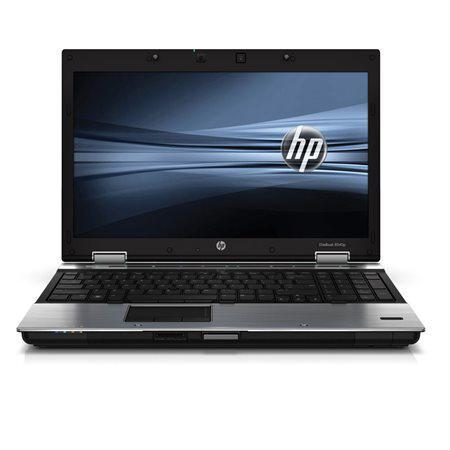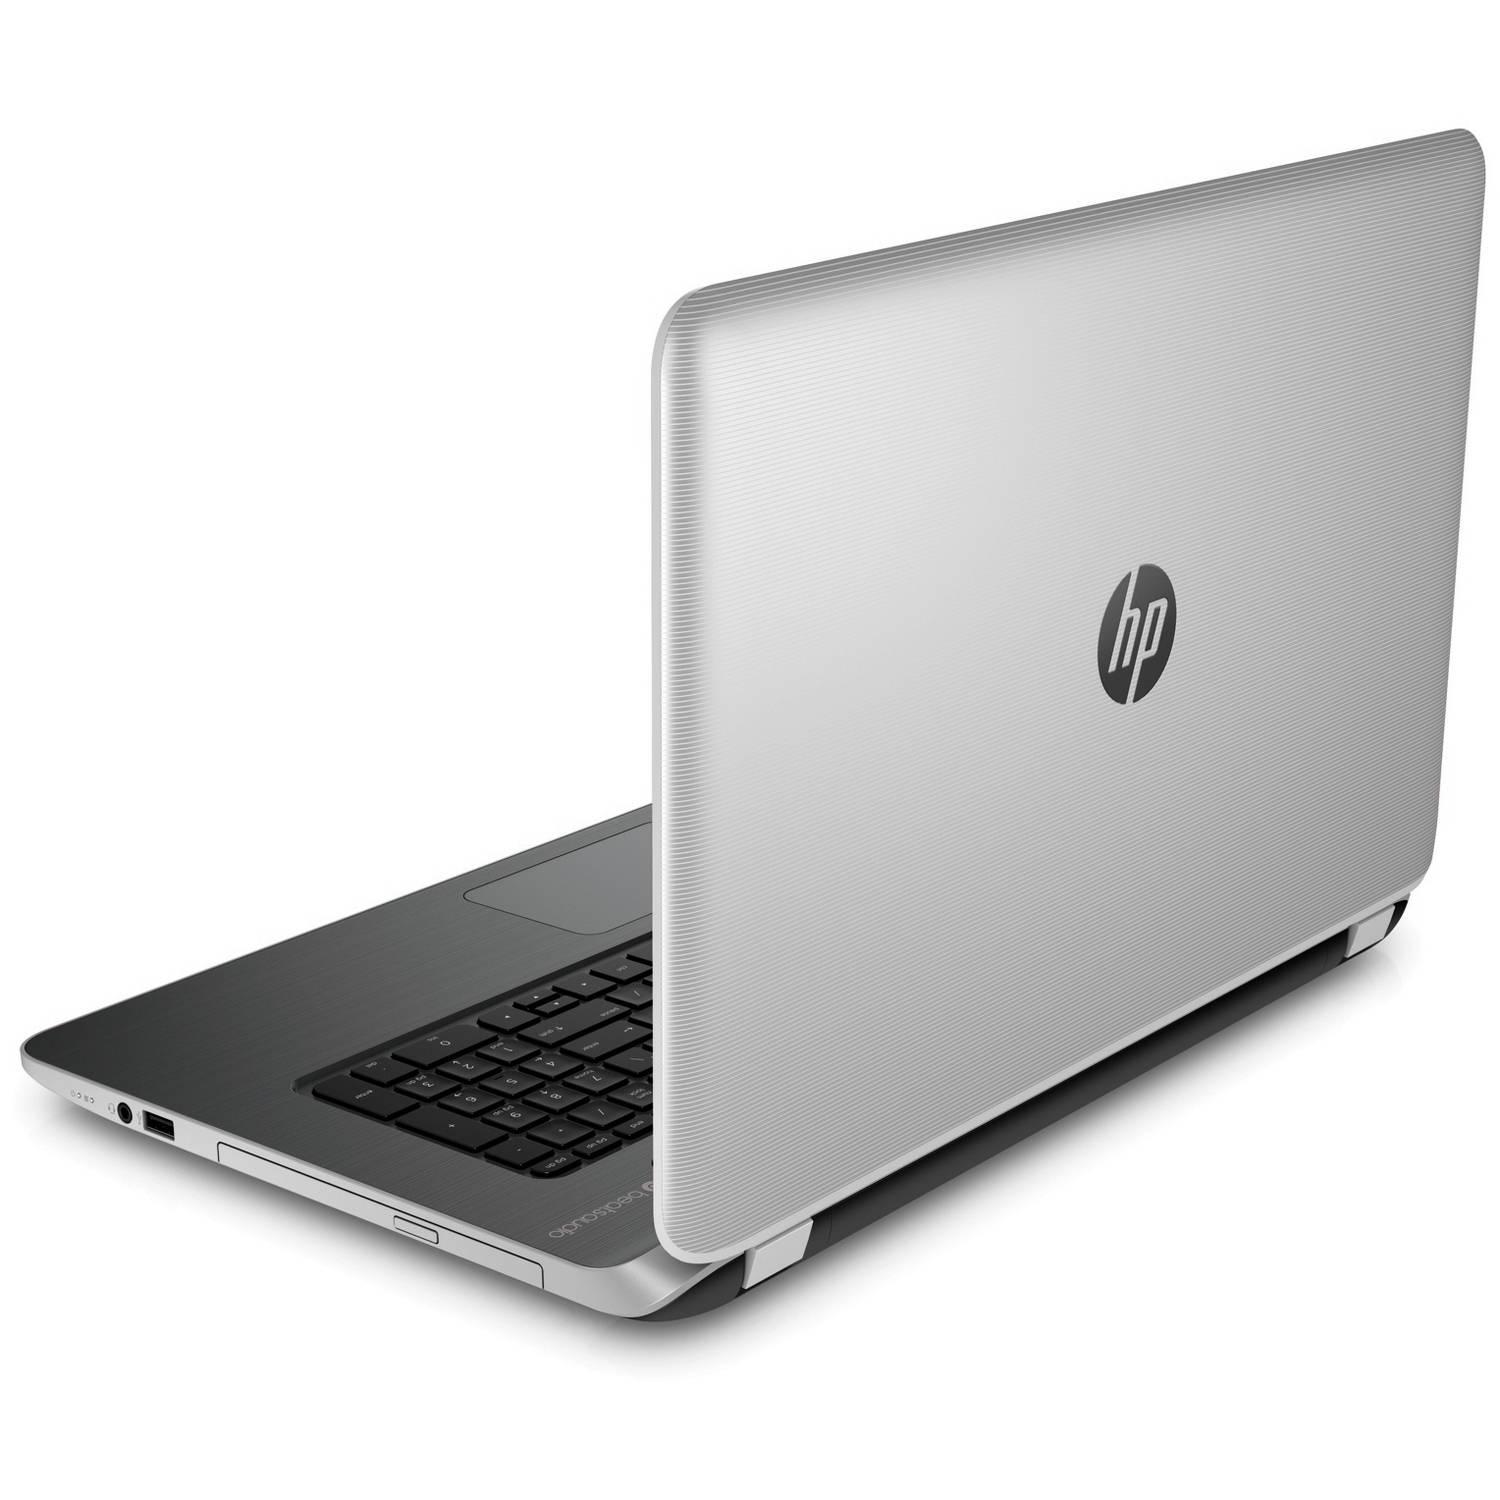The first image is the image on the left, the second image is the image on the right. Examine the images to the left and right. Is the description "One laptop is facing directly forward, and another laptop is facing diagonally backward." accurate? Answer yes or no. Yes. The first image is the image on the left, the second image is the image on the right. Considering the images on both sides, is "One open laptop is displayed head-on, and the other open laptop is displayed at an angle with its screen facing away from the camera toward the left." valid? Answer yes or no. Yes. 